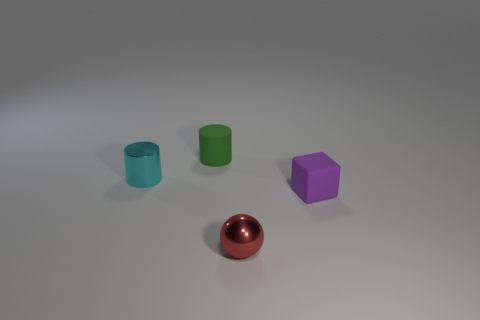Add 4 yellow rubber things. How many objects exist? 8 Subtract all spheres. How many objects are left? 3 Add 4 tiny rubber cylinders. How many tiny rubber cylinders are left? 5 Add 2 green matte cylinders. How many green matte cylinders exist? 3 Subtract 0 cyan spheres. How many objects are left? 4 Subtract all cyan shiny objects. Subtract all rubber cylinders. How many objects are left? 2 